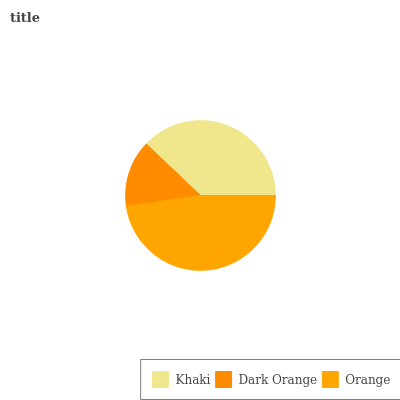Is Dark Orange the minimum?
Answer yes or no. Yes. Is Orange the maximum?
Answer yes or no. Yes. Is Orange the minimum?
Answer yes or no. No. Is Dark Orange the maximum?
Answer yes or no. No. Is Orange greater than Dark Orange?
Answer yes or no. Yes. Is Dark Orange less than Orange?
Answer yes or no. Yes. Is Dark Orange greater than Orange?
Answer yes or no. No. Is Orange less than Dark Orange?
Answer yes or no. No. Is Khaki the high median?
Answer yes or no. Yes. Is Khaki the low median?
Answer yes or no. Yes. Is Dark Orange the high median?
Answer yes or no. No. Is Orange the low median?
Answer yes or no. No. 